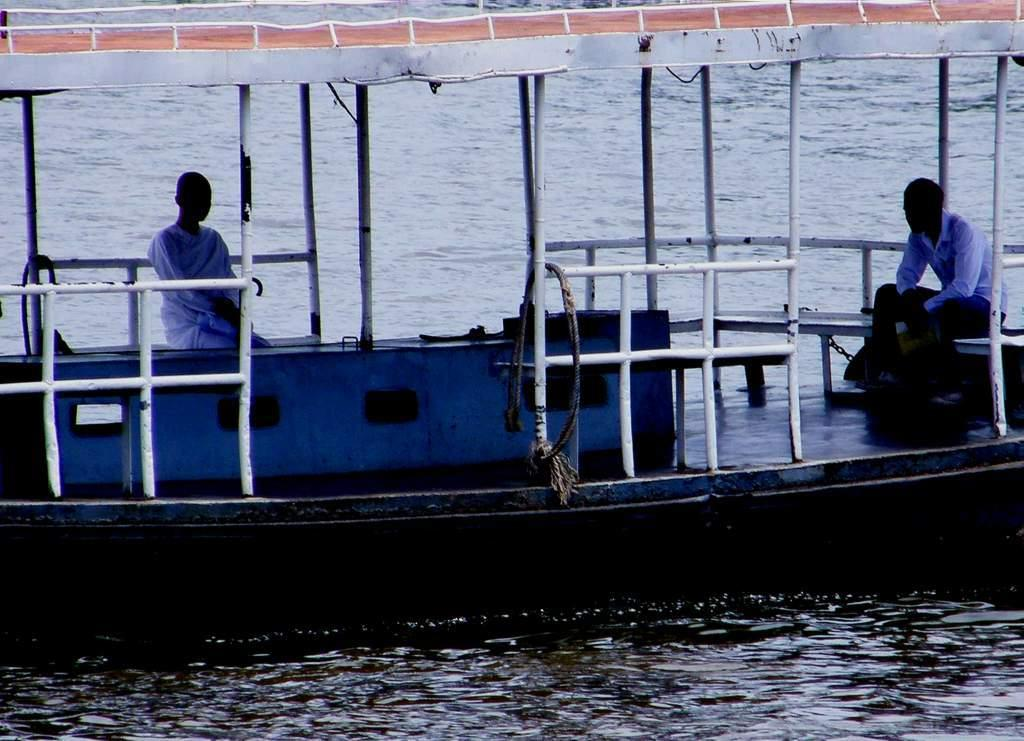How many people are in the image? There are two people in the image. What are the two people doing in the image? The two people are sitting on a boat. Where is the boat located in the image? The boat is sailing on the water. What type of book is the person reading on the boat? There is no book present in the image; the two people are sitting on a boat sailing on the water. 